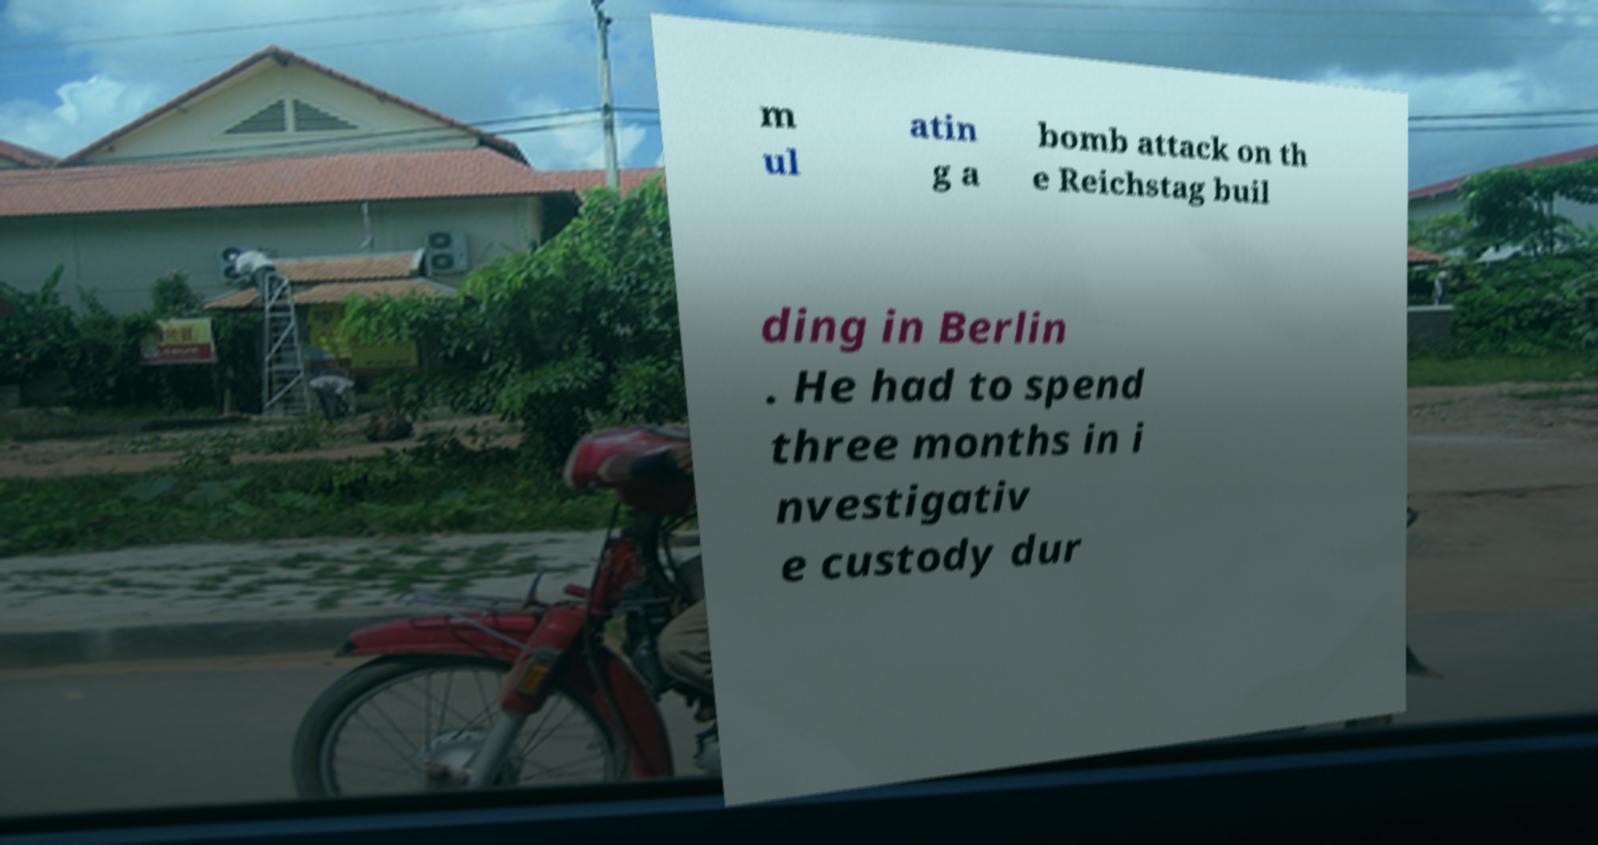There's text embedded in this image that I need extracted. Can you transcribe it verbatim? m ul atin g a bomb attack on th e Reichstag buil ding in Berlin . He had to spend three months in i nvestigativ e custody dur 